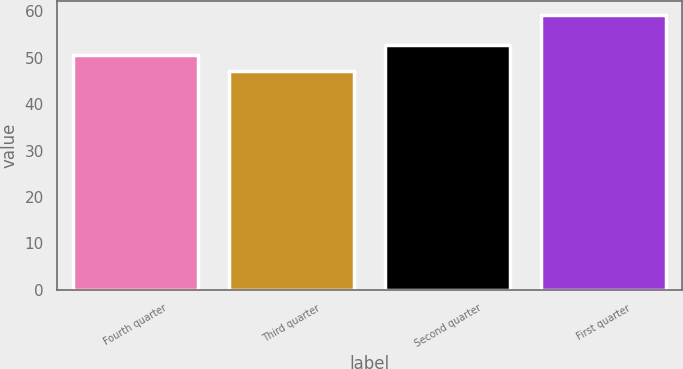Convert chart to OTSL. <chart><loc_0><loc_0><loc_500><loc_500><bar_chart><fcel>Fourth quarter<fcel>Third quarter<fcel>Second quarter<fcel>First quarter<nl><fcel>50.63<fcel>47.21<fcel>52.87<fcel>59.2<nl></chart> 